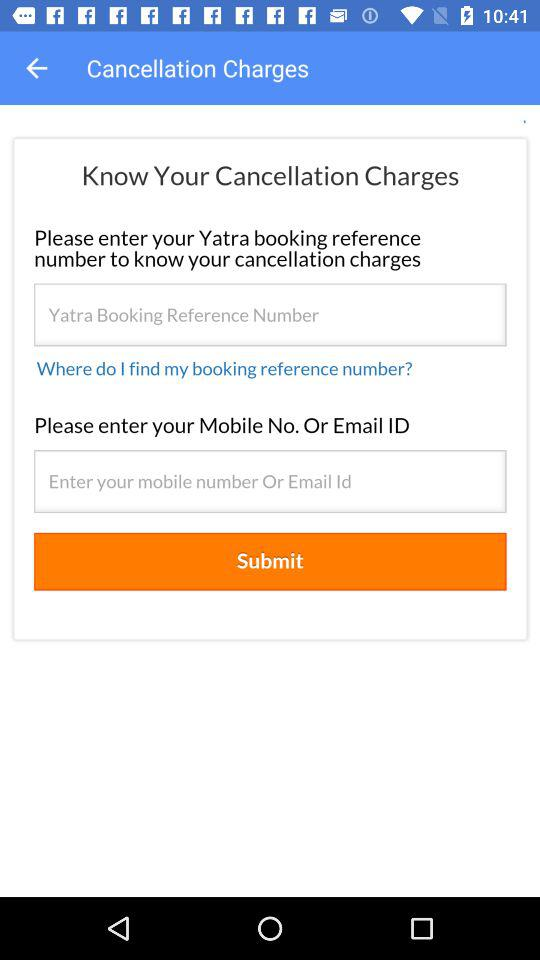How many fields do I need to fill in to know my cancellation charges?
Answer the question using a single word or phrase. 2 